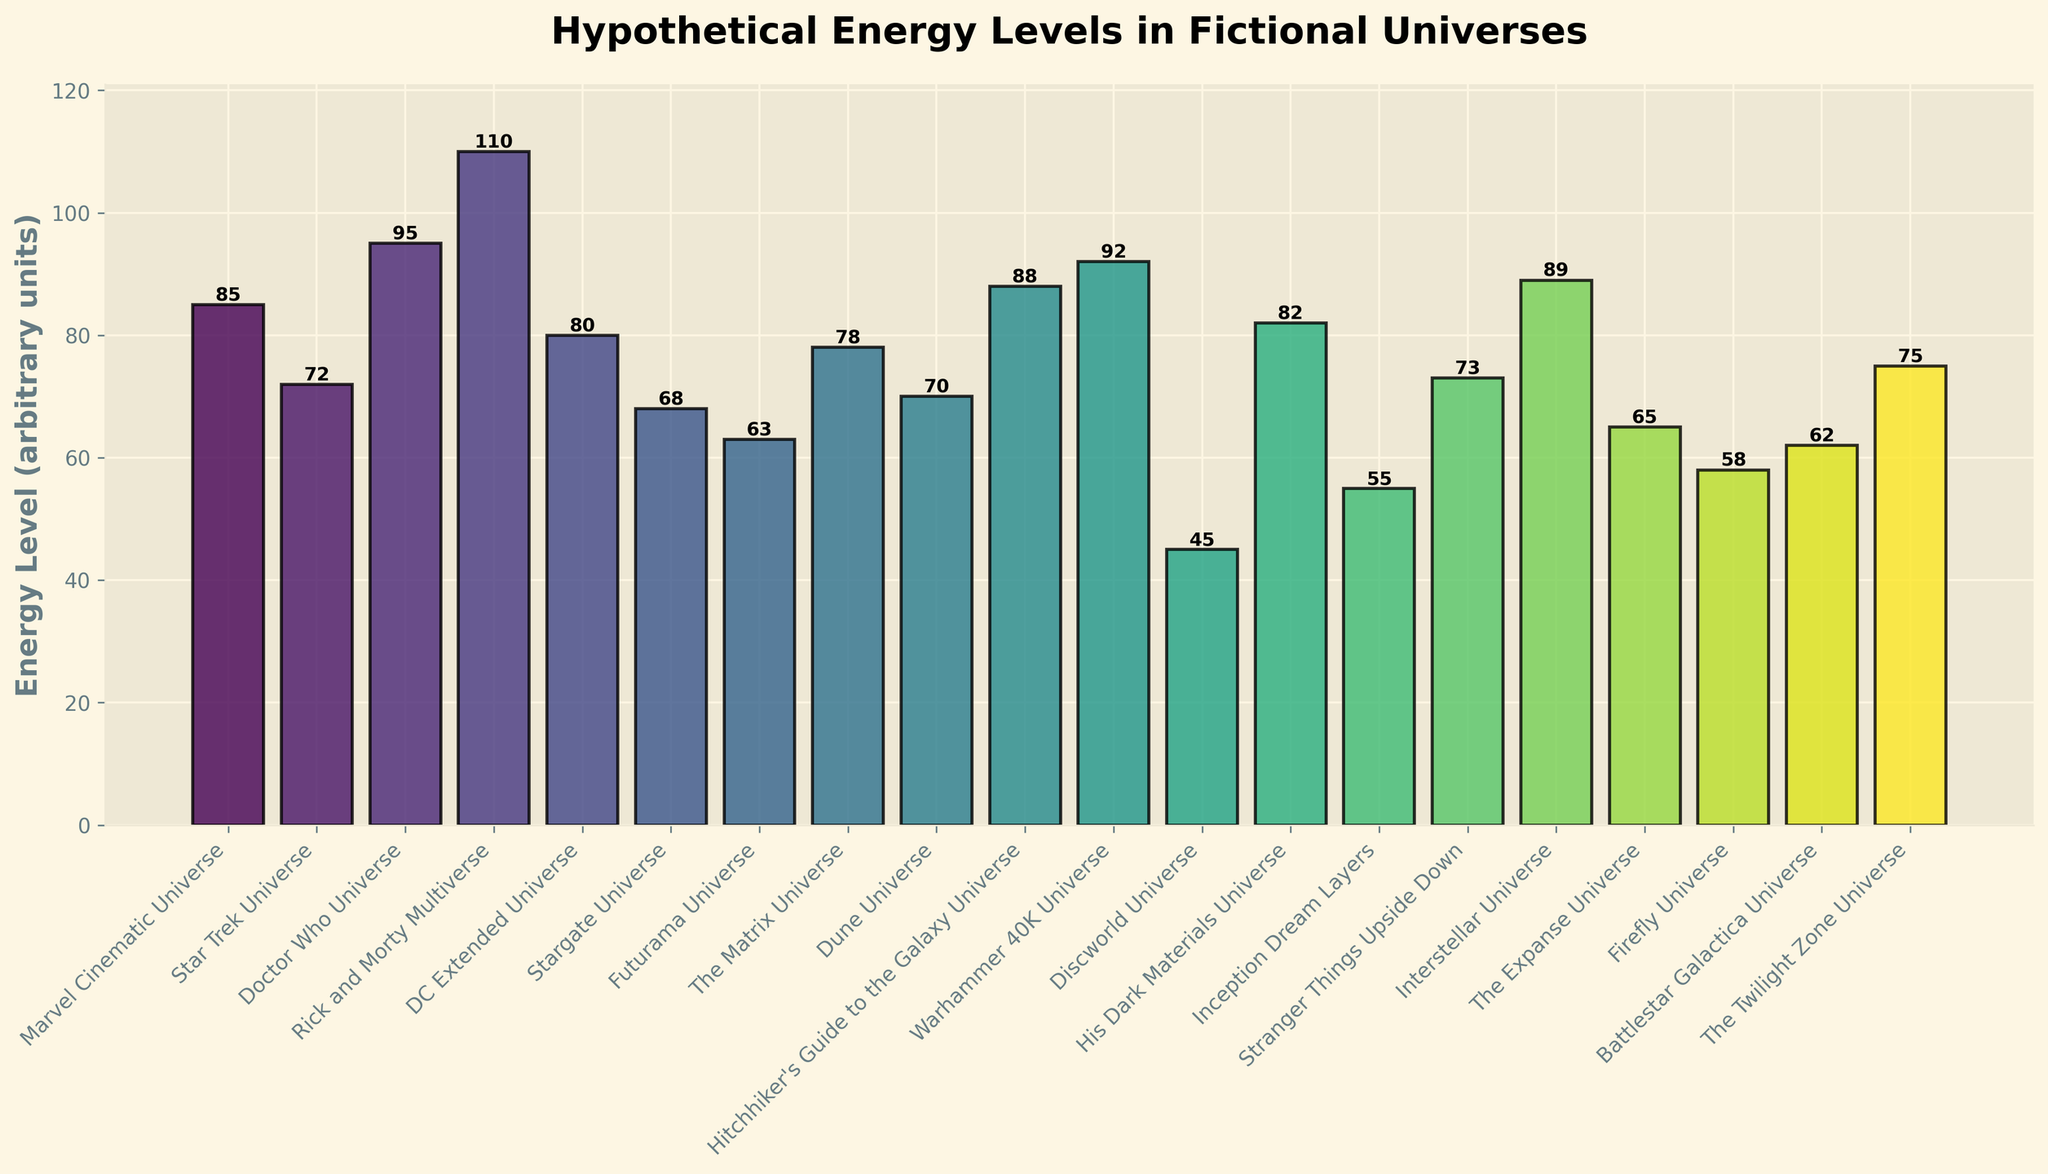What is the highest energy level among the universes? The highest energy level can be found by looking at the tallest bar in the chart.
Answer: Rick and Morty Multiverse Which universe has a higher energy level: Star Trek Universe or The Expanse Universe? Compare the heights of the bars for both universes. Star Trek Universe has a bar height of 72, and The Expanse Universe has a bar height of 65.
Answer: Star Trek Universe What is the total energy level of Marvel Cinematic Universe and DC Extended Universe combined? Add the energy levels of Marvel Cinematic Universe (85) and DC Extended Universe (80). 85 + 80 = 165
Answer: 165 Which universe has the lowest energy level and what is its value? Look for the shortest bar in the chart and read its label and value.
Answer: Discworld Universe, 45 By how much does the energy level of Rick and Morty Multiverse exceed that of Stranger Things Upside Down? Subtract the energy level of Stranger Things Upside Down (73) from Rick and Morty Multiverse (110). 110 - 73 = 37
Answer: 37 What is the average energy level across all the universes? Sum all the energy levels and divide by the number of universes. (85 + 72 + 95 + 110 + 80 + 68 + 63 + 78 + 70 + 88 + 92 + 45 + 82 + 55 + 73 + 89 + 65 + 58 + 62 + 75) / 20 = 76.4
Answer: 76.4 Which universe's energy level is just below the Hitchhiker's Guide to the Galaxy Universe? Identify the bar just below 88 (Hitchhiker's Guide to the Galaxy Universe), which is Interstellar Universe with 89.
Answer: Warhammer 40K Universe How many universes have an energy level of 80 or higher? Count the number of bars with a height of 80 or higher. There are Marvel Cinematic Universe (85), Doctor Who Universe (95), Rick and Morty Multiverse (110), DC Extended Universe (80), Hitchhiker's Guide to the Galaxy Universe (88), Warhammer 40K Universe (92), and Interstellar Universe (89).
Answer: 7 What is the difference between the highest energy level and the lowest energy level? Subtract the lowest energy level (Discworld Universe, 45) from the highest energy level (Rick and Morty Multiverse, 110). 110 - 45 = 65
Answer: 65 Which two universes have an energy level closest to each other? Find bars with minimum height difference. The closest energy levels are Star Trek Universe (72) and Stranger Things Upside Down (73).
Answer: Star Trek Universe and Stranger Things Upside Down 